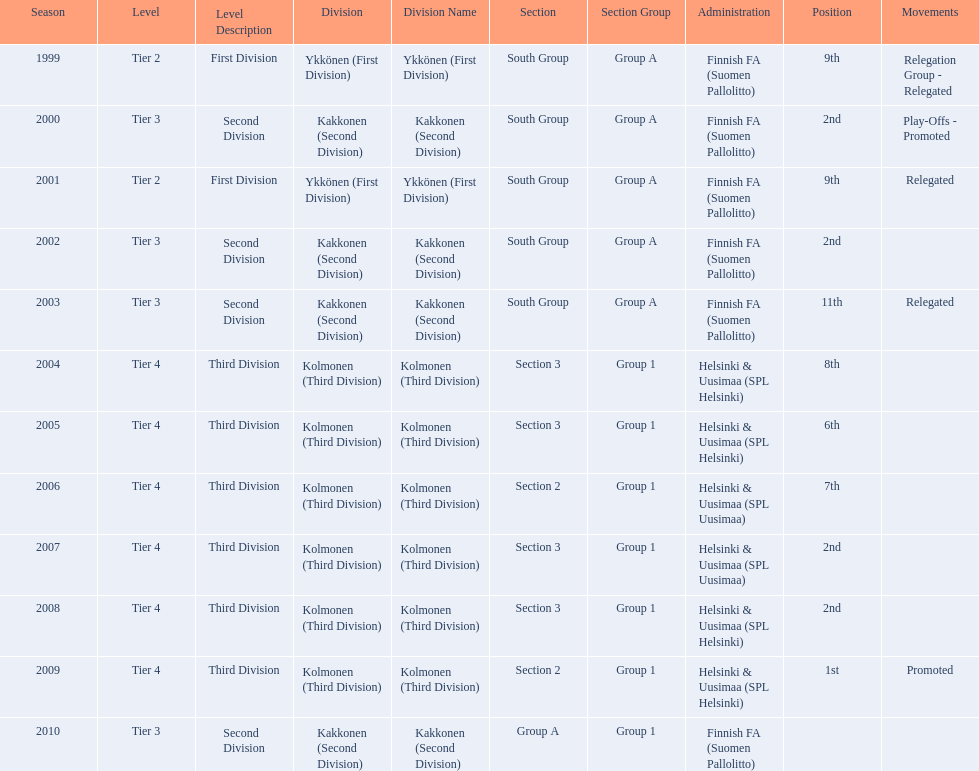What position did this team get after getting 9th place in 1999? 2nd. Parse the full table. {'header': ['Season', 'Level', 'Level Description', 'Division', 'Division Name', 'Section', 'Section Group', 'Administration', 'Position', 'Movements'], 'rows': [['1999', 'Tier 2', 'First Division', 'Ykkönen (First Division)', 'Ykkönen (First Division)', 'South Group', 'Group A', 'Finnish FA (Suomen Pallolitto)', '9th', 'Relegation Group - Relegated'], ['2000', 'Tier 3', 'Second Division', 'Kakkonen (Second Division)', 'Kakkonen (Second Division)', 'South Group', 'Group A', 'Finnish FA (Suomen Pallolitto)', '2nd', 'Play-Offs - Promoted'], ['2001', 'Tier 2', 'First Division', 'Ykkönen (First Division)', 'Ykkönen (First Division)', 'South Group', 'Group A', 'Finnish FA (Suomen Pallolitto)', '9th', 'Relegated'], ['2002', 'Tier 3', 'Second Division', 'Kakkonen (Second Division)', 'Kakkonen (Second Division)', 'South Group', 'Group A', 'Finnish FA (Suomen Pallolitto)', '2nd', ''], ['2003', 'Tier 3', 'Second Division', 'Kakkonen (Second Division)', 'Kakkonen (Second Division)', 'South Group', 'Group A', 'Finnish FA (Suomen Pallolitto)', '11th', 'Relegated'], ['2004', 'Tier 4', 'Third Division', 'Kolmonen (Third Division)', 'Kolmonen (Third Division)', 'Section 3', 'Group 1', 'Helsinki & Uusimaa (SPL Helsinki)', '8th', ''], ['2005', 'Tier 4', 'Third Division', 'Kolmonen (Third Division)', 'Kolmonen (Third Division)', 'Section 3', 'Group 1', 'Helsinki & Uusimaa (SPL Helsinki)', '6th', ''], ['2006', 'Tier 4', 'Third Division', 'Kolmonen (Third Division)', 'Kolmonen (Third Division)', 'Section 2', 'Group 1', 'Helsinki & Uusimaa (SPL Uusimaa)', '7th', ''], ['2007', 'Tier 4', 'Third Division', 'Kolmonen (Third Division)', 'Kolmonen (Third Division)', 'Section 3', 'Group 1', 'Helsinki & Uusimaa (SPL Uusimaa)', '2nd', ''], ['2008', 'Tier 4', 'Third Division', 'Kolmonen (Third Division)', 'Kolmonen (Third Division)', 'Section 3', 'Group 1', 'Helsinki & Uusimaa (SPL Helsinki)', '2nd', ''], ['2009', 'Tier 4', 'Third Division', 'Kolmonen (Third Division)', 'Kolmonen (Third Division)', 'Section 2', 'Group 1', 'Helsinki & Uusimaa (SPL Helsinki)', '1st', 'Promoted'], ['2010', 'Tier 3', 'Second Division', 'Kakkonen (Second Division)', 'Kakkonen (Second Division)', 'Group A', 'Group 1', 'Finnish FA (Suomen Pallolitto)', '', '']]} 